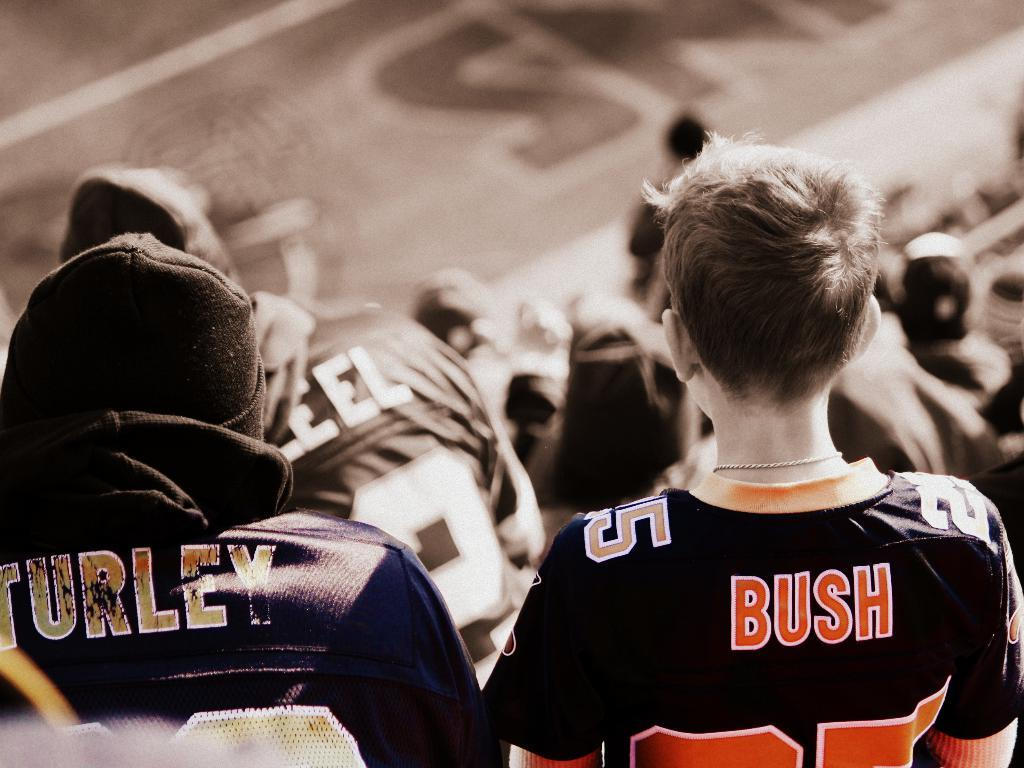<image>
Offer a succinct explanation of the picture presented. the boy is wearing a black jersey saying Bush on the back 